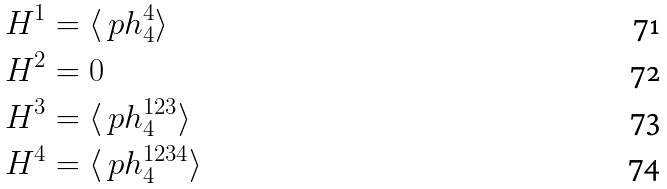Convert formula to latex. <formula><loc_0><loc_0><loc_500><loc_500>H ^ { 1 } & = \langle \ p h ^ { 4 } _ { 4 } \rangle \\ H ^ { 2 } & = 0 \\ H ^ { 3 } & = \langle \ p h ^ { 1 2 3 } _ { 4 } \rangle \\ H ^ { 4 } & = \langle \ p h ^ { 1 2 3 4 } _ { 4 } \rangle</formula> 